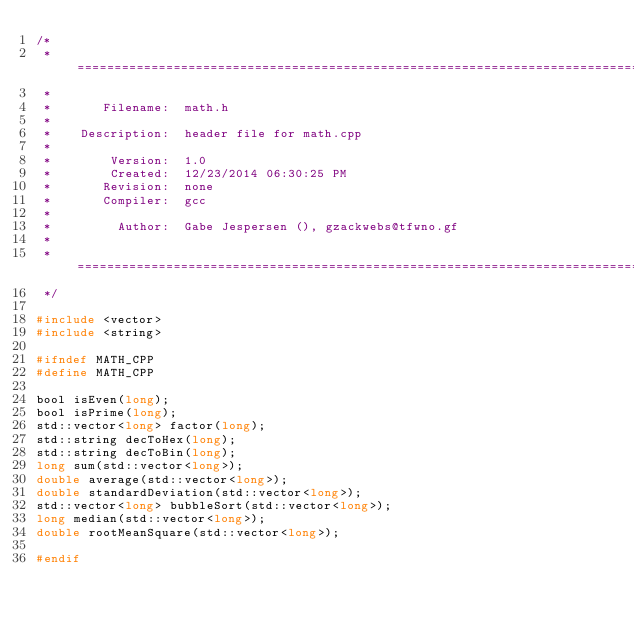Convert code to text. <code><loc_0><loc_0><loc_500><loc_500><_C_>/*
 * =====================================================================================
 *
 *       Filename:  math.h
 *
 *    Description:  header file for math.cpp
 *
 *        Version:  1.0
 *        Created:  12/23/2014 06:30:25 PM
 *       Revision:  none
 *       Compiler:  gcc
 *
 *         Author:  Gabe Jespersen (), gzackwebs@tfwno.gf
 *
 * =====================================================================================
 */

#include <vector>
#include <string>

#ifndef MATH_CPP
#define MATH_CPP

bool isEven(long);
bool isPrime(long);
std::vector<long> factor(long);
std::string decToHex(long);
std::string decToBin(long);
long sum(std::vector<long>);
double average(std::vector<long>);
double standardDeviation(std::vector<long>);
std::vector<long> bubbleSort(std::vector<long>);
long median(std::vector<long>);
double rootMeanSquare(std::vector<long>);

#endif
</code> 